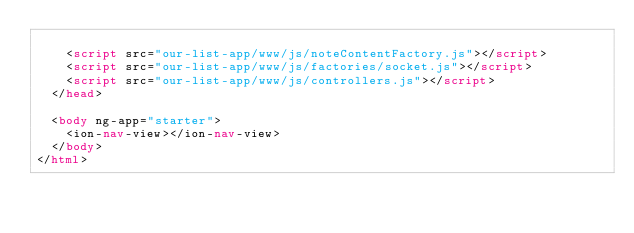Convert code to text. <code><loc_0><loc_0><loc_500><loc_500><_HTML_>
    <script src="our-list-app/www/js/noteContentFactory.js"></script>
    <script src="our-list-app/www/js/factories/socket.js"></script>
    <script src="our-list-app/www/js/controllers.js"></script>
  </head>

  <body ng-app="starter">
    <ion-nav-view></ion-nav-view>
  </body>
</html>
</code> 